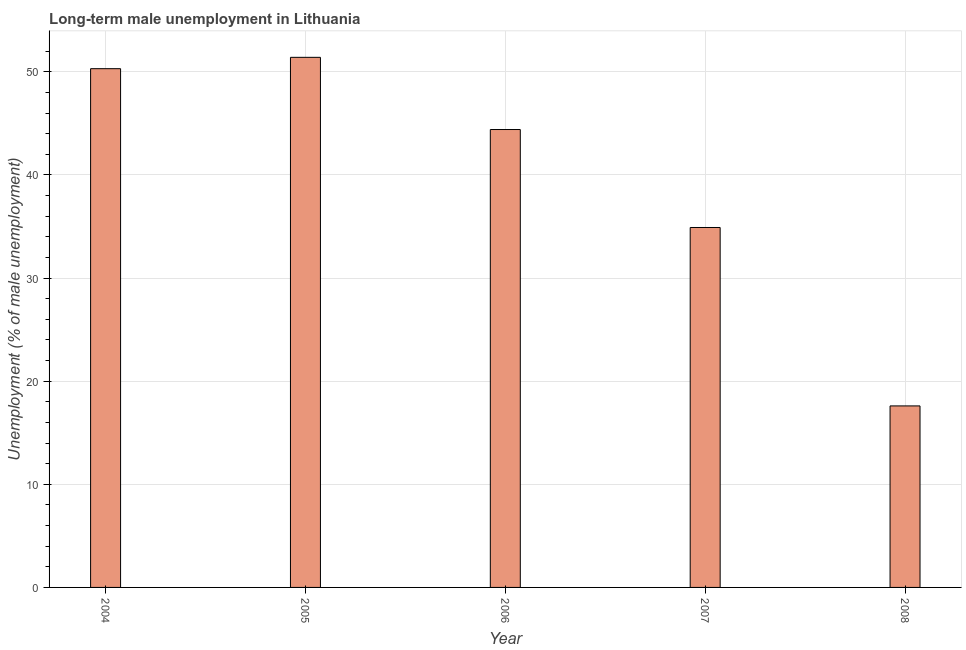Does the graph contain any zero values?
Offer a terse response. No. Does the graph contain grids?
Your answer should be compact. Yes. What is the title of the graph?
Provide a succinct answer. Long-term male unemployment in Lithuania. What is the label or title of the Y-axis?
Provide a succinct answer. Unemployment (% of male unemployment). What is the long-term male unemployment in 2008?
Ensure brevity in your answer.  17.6. Across all years, what is the maximum long-term male unemployment?
Offer a terse response. 51.4. Across all years, what is the minimum long-term male unemployment?
Your response must be concise. 17.6. In which year was the long-term male unemployment maximum?
Make the answer very short. 2005. What is the sum of the long-term male unemployment?
Offer a very short reply. 198.6. What is the average long-term male unemployment per year?
Ensure brevity in your answer.  39.72. What is the median long-term male unemployment?
Keep it short and to the point. 44.4. What is the ratio of the long-term male unemployment in 2005 to that in 2008?
Ensure brevity in your answer.  2.92. Is the long-term male unemployment in 2006 less than that in 2007?
Ensure brevity in your answer.  No. Is the difference between the long-term male unemployment in 2004 and 2007 greater than the difference between any two years?
Keep it short and to the point. No. Is the sum of the long-term male unemployment in 2005 and 2008 greater than the maximum long-term male unemployment across all years?
Ensure brevity in your answer.  Yes. What is the difference between the highest and the lowest long-term male unemployment?
Give a very brief answer. 33.8. In how many years, is the long-term male unemployment greater than the average long-term male unemployment taken over all years?
Make the answer very short. 3. How many years are there in the graph?
Offer a terse response. 5. What is the difference between two consecutive major ticks on the Y-axis?
Your response must be concise. 10. Are the values on the major ticks of Y-axis written in scientific E-notation?
Your answer should be very brief. No. What is the Unemployment (% of male unemployment) in 2004?
Give a very brief answer. 50.3. What is the Unemployment (% of male unemployment) in 2005?
Offer a terse response. 51.4. What is the Unemployment (% of male unemployment) of 2006?
Offer a terse response. 44.4. What is the Unemployment (% of male unemployment) of 2007?
Give a very brief answer. 34.9. What is the Unemployment (% of male unemployment) in 2008?
Your response must be concise. 17.6. What is the difference between the Unemployment (% of male unemployment) in 2004 and 2006?
Offer a very short reply. 5.9. What is the difference between the Unemployment (% of male unemployment) in 2004 and 2007?
Provide a succinct answer. 15.4. What is the difference between the Unemployment (% of male unemployment) in 2004 and 2008?
Give a very brief answer. 32.7. What is the difference between the Unemployment (% of male unemployment) in 2005 and 2006?
Provide a short and direct response. 7. What is the difference between the Unemployment (% of male unemployment) in 2005 and 2007?
Ensure brevity in your answer.  16.5. What is the difference between the Unemployment (% of male unemployment) in 2005 and 2008?
Provide a short and direct response. 33.8. What is the difference between the Unemployment (% of male unemployment) in 2006 and 2008?
Offer a terse response. 26.8. What is the ratio of the Unemployment (% of male unemployment) in 2004 to that in 2005?
Provide a succinct answer. 0.98. What is the ratio of the Unemployment (% of male unemployment) in 2004 to that in 2006?
Provide a succinct answer. 1.13. What is the ratio of the Unemployment (% of male unemployment) in 2004 to that in 2007?
Provide a succinct answer. 1.44. What is the ratio of the Unemployment (% of male unemployment) in 2004 to that in 2008?
Your response must be concise. 2.86. What is the ratio of the Unemployment (% of male unemployment) in 2005 to that in 2006?
Your answer should be very brief. 1.16. What is the ratio of the Unemployment (% of male unemployment) in 2005 to that in 2007?
Your response must be concise. 1.47. What is the ratio of the Unemployment (% of male unemployment) in 2005 to that in 2008?
Make the answer very short. 2.92. What is the ratio of the Unemployment (% of male unemployment) in 2006 to that in 2007?
Make the answer very short. 1.27. What is the ratio of the Unemployment (% of male unemployment) in 2006 to that in 2008?
Ensure brevity in your answer.  2.52. What is the ratio of the Unemployment (% of male unemployment) in 2007 to that in 2008?
Provide a short and direct response. 1.98. 